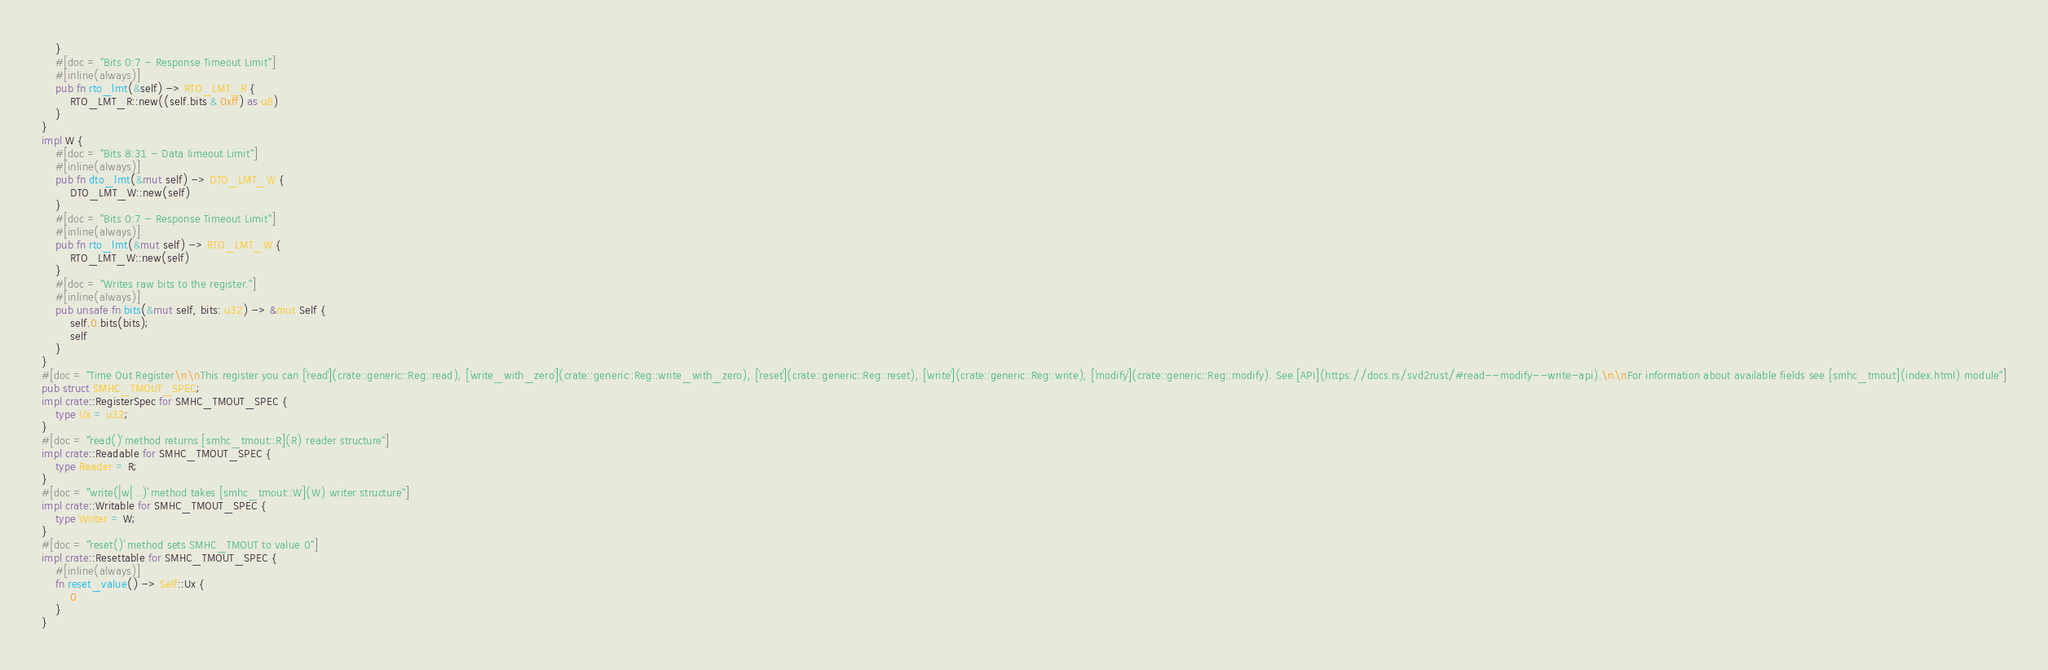Convert code to text. <code><loc_0><loc_0><loc_500><loc_500><_Rust_>    }
    #[doc = "Bits 0:7 - Response Timeout Limit"]
    #[inline(always)]
    pub fn rto_lmt(&self) -> RTO_LMT_R {
        RTO_LMT_R::new((self.bits & 0xff) as u8)
    }
}
impl W {
    #[doc = "Bits 8:31 - Data Iimeout Limit"]
    #[inline(always)]
    pub fn dto_lmt(&mut self) -> DTO_LMT_W {
        DTO_LMT_W::new(self)
    }
    #[doc = "Bits 0:7 - Response Timeout Limit"]
    #[inline(always)]
    pub fn rto_lmt(&mut self) -> RTO_LMT_W {
        RTO_LMT_W::new(self)
    }
    #[doc = "Writes raw bits to the register."]
    #[inline(always)]
    pub unsafe fn bits(&mut self, bits: u32) -> &mut Self {
        self.0.bits(bits);
        self
    }
}
#[doc = "Time Out Register\n\nThis register you can [`read`](crate::generic::Reg::read), [`write_with_zero`](crate::generic::Reg::write_with_zero), [`reset`](crate::generic::Reg::reset), [`write`](crate::generic::Reg::write), [`modify`](crate::generic::Reg::modify). See [API](https://docs.rs/svd2rust/#read--modify--write-api).\n\nFor information about available fields see [smhc_tmout](index.html) module"]
pub struct SMHC_TMOUT_SPEC;
impl crate::RegisterSpec for SMHC_TMOUT_SPEC {
    type Ux = u32;
}
#[doc = "`read()` method returns [smhc_tmout::R](R) reader structure"]
impl crate::Readable for SMHC_TMOUT_SPEC {
    type Reader = R;
}
#[doc = "`write(|w| ..)` method takes [smhc_tmout::W](W) writer structure"]
impl crate::Writable for SMHC_TMOUT_SPEC {
    type Writer = W;
}
#[doc = "`reset()` method sets SMHC_TMOUT to value 0"]
impl crate::Resettable for SMHC_TMOUT_SPEC {
    #[inline(always)]
    fn reset_value() -> Self::Ux {
        0
    }
}
</code> 